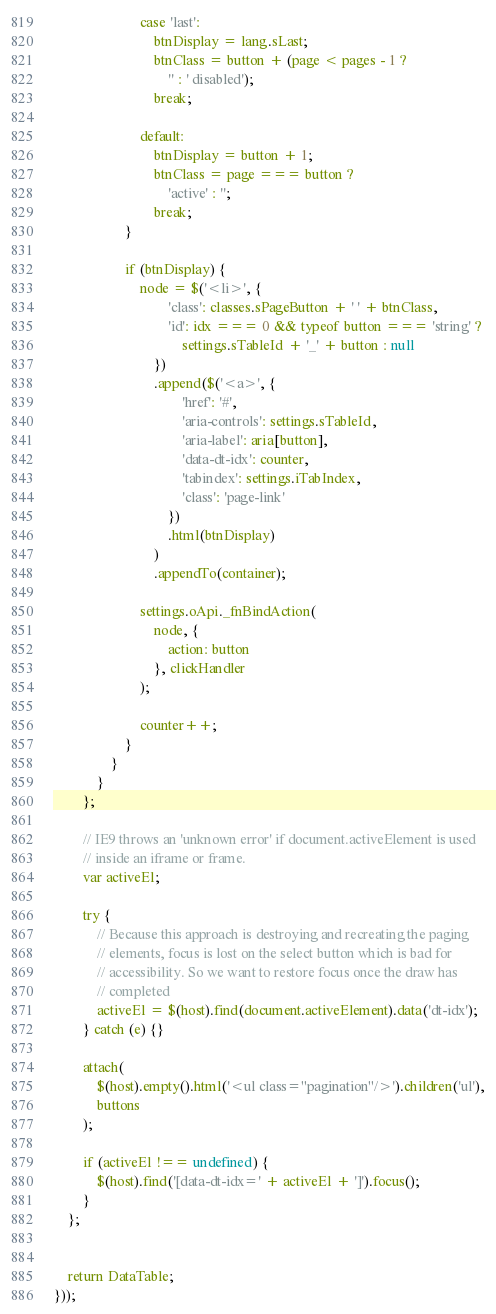Convert code to text. <code><loc_0><loc_0><loc_500><loc_500><_JavaScript_>						case 'last':
							btnDisplay = lang.sLast;
							btnClass = button + (page < pages - 1 ?
								'' : ' disabled');
							break;

						default:
							btnDisplay = button + 1;
							btnClass = page === button ?
								'active' : '';
							break;
					}

					if (btnDisplay) {
						node = $('<li>', {
								'class': classes.sPageButton + ' ' + btnClass,
								'id': idx === 0 && typeof button === 'string' ?
									settings.sTableId + '_' + button : null
							})
							.append($('<a>', {
									'href': '#',
									'aria-controls': settings.sTableId,
									'aria-label': aria[button],
									'data-dt-idx': counter,
									'tabindex': settings.iTabIndex,
									'class': 'page-link'
								})
								.html(btnDisplay)
							)
							.appendTo(container);

						settings.oApi._fnBindAction(
							node, {
								action: button
							}, clickHandler
						);

						counter++;
					}
				}
			}
		};

		// IE9 throws an 'unknown error' if document.activeElement is used
		// inside an iframe or frame. 
		var activeEl;

		try {
			// Because this approach is destroying and recreating the paging
			// elements, focus is lost on the select button which is bad for
			// accessibility. So we want to restore focus once the draw has
			// completed
			activeEl = $(host).find(document.activeElement).data('dt-idx');
		} catch (e) {}

		attach(
			$(host).empty().html('<ul class="pagination"/>').children('ul'),
			buttons
		);

		if (activeEl !== undefined) {
			$(host).find('[data-dt-idx=' + activeEl + ']').focus();
		}
	};


	return DataTable;
}));</code> 